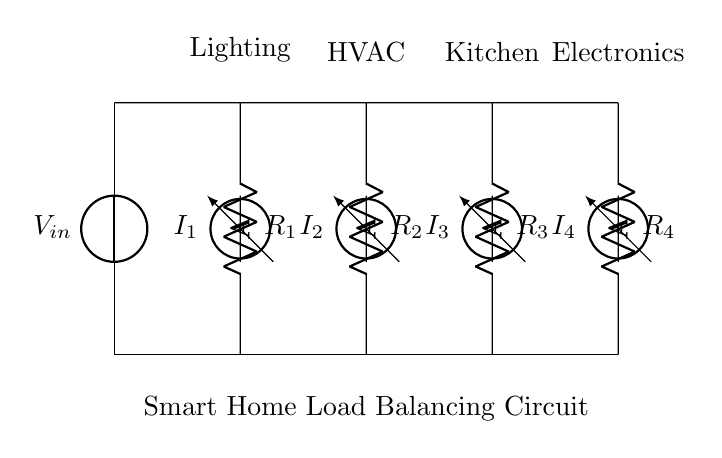What is the input voltage of this circuit? The input voltage is indicated at the source and labeled as V in. This is typically assumed to be provided by the electrical system in the home.
Answer: V in What are the different loads connected in this circuit? The circuit diagram specifies four loads: Lighting, HVAC, Kitchen, and Electronics. Each is associated with a resistor indicating their respective connections in the circuit.
Answer: Lighting, HVAC, Kitchen, Electronics What type of circuit configuration is this? The circuit is a parallel configuration where multiple resistors (loads) are connected across the same voltage source. Each resistor allows a portion of the total current to flow, minimizing impacts on other loads.
Answer: Parallel How many ammeters are present in the circuit? There are four ammeters in the circuit, each measuring the current through one of the connected loads (R1, R2, R3, R4).
Answer: 4 What is the purpose of using a current divider in this circuit? The current divider is used to distribute the total current from the input voltage source among the different connected loads equally based on their resistance values, ensuring they operate effectively without overload.
Answer: Load balancing Which load has the highest current flow? The load with the lowest resistance will draw the highest current, as current is inversely proportional to resistance in a parallel circuit. Thus, without specific resistance values, it is not directly answerable, but typically the load assumed to have the lowest resistance will have the highest current flow.
Answer: Depends on resistance values 